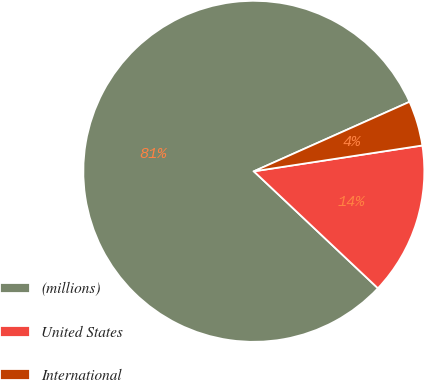Convert chart to OTSL. <chart><loc_0><loc_0><loc_500><loc_500><pie_chart><fcel>(millions)<fcel>United States<fcel>International<nl><fcel>81.29%<fcel>14.45%<fcel>4.26%<nl></chart> 